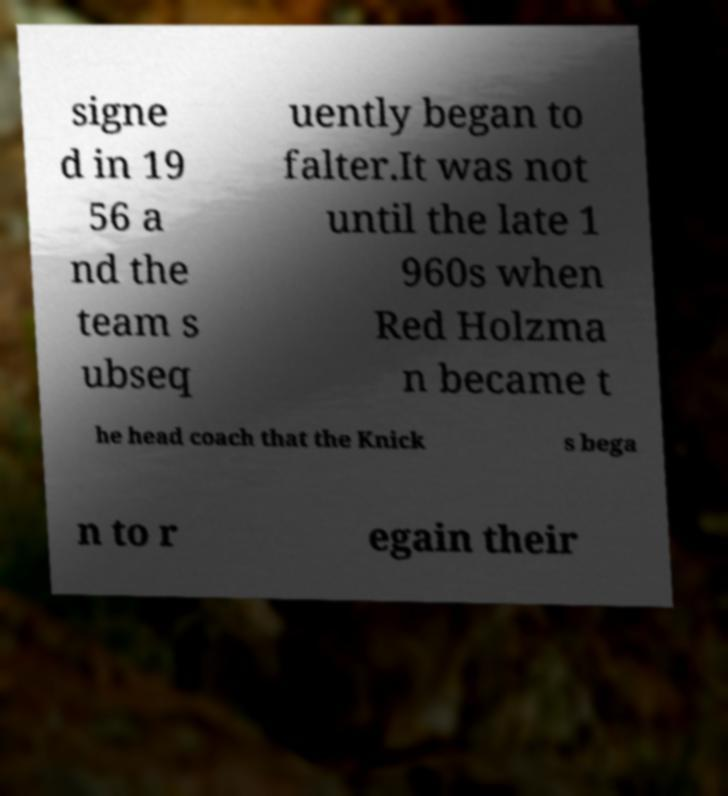Please identify and transcribe the text found in this image. signe d in 19 56 a nd the team s ubseq uently began to falter.It was not until the late 1 960s when Red Holzma n became t he head coach that the Knick s bega n to r egain their 